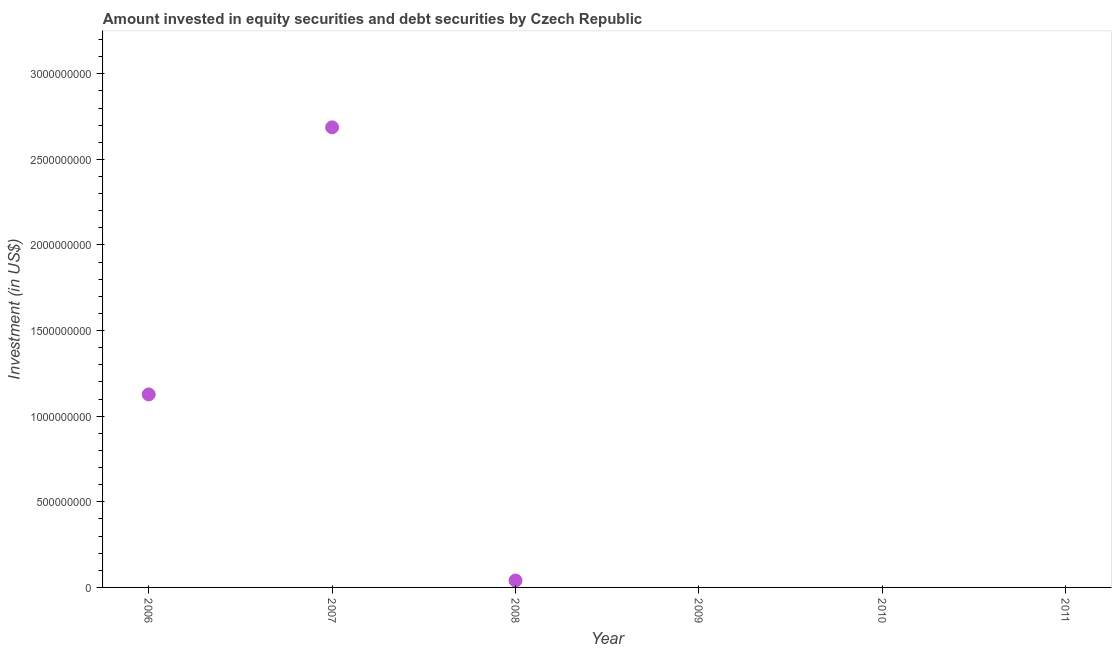What is the portfolio investment in 2008?
Keep it short and to the point. 4.03e+07. Across all years, what is the maximum portfolio investment?
Give a very brief answer. 2.69e+09. What is the sum of the portfolio investment?
Your answer should be compact. 3.85e+09. What is the difference between the portfolio investment in 2006 and 2008?
Your answer should be compact. 1.09e+09. What is the average portfolio investment per year?
Your response must be concise. 6.42e+08. What is the median portfolio investment?
Your answer should be compact. 2.02e+07. Is the portfolio investment in 2006 less than that in 2008?
Offer a very short reply. No. Is the difference between the portfolio investment in 2006 and 2008 greater than the difference between any two years?
Give a very brief answer. No. What is the difference between the highest and the second highest portfolio investment?
Your answer should be compact. 1.56e+09. What is the difference between the highest and the lowest portfolio investment?
Make the answer very short. 2.69e+09. How many years are there in the graph?
Offer a terse response. 6. What is the difference between two consecutive major ticks on the Y-axis?
Your answer should be very brief. 5.00e+08. Are the values on the major ticks of Y-axis written in scientific E-notation?
Offer a very short reply. No. Does the graph contain any zero values?
Ensure brevity in your answer.  Yes. What is the title of the graph?
Offer a terse response. Amount invested in equity securities and debt securities by Czech Republic. What is the label or title of the Y-axis?
Offer a very short reply. Investment (in US$). What is the Investment (in US$) in 2006?
Keep it short and to the point. 1.13e+09. What is the Investment (in US$) in 2007?
Make the answer very short. 2.69e+09. What is the Investment (in US$) in 2008?
Keep it short and to the point. 4.03e+07. What is the Investment (in US$) in 2010?
Your answer should be very brief. 0. What is the Investment (in US$) in 2011?
Provide a short and direct response. 0. What is the difference between the Investment (in US$) in 2006 and 2007?
Provide a succinct answer. -1.56e+09. What is the difference between the Investment (in US$) in 2006 and 2008?
Provide a succinct answer. 1.09e+09. What is the difference between the Investment (in US$) in 2007 and 2008?
Offer a terse response. 2.65e+09. What is the ratio of the Investment (in US$) in 2006 to that in 2007?
Offer a very short reply. 0.42. What is the ratio of the Investment (in US$) in 2006 to that in 2008?
Provide a succinct answer. 27.96. What is the ratio of the Investment (in US$) in 2007 to that in 2008?
Provide a short and direct response. 66.65. 